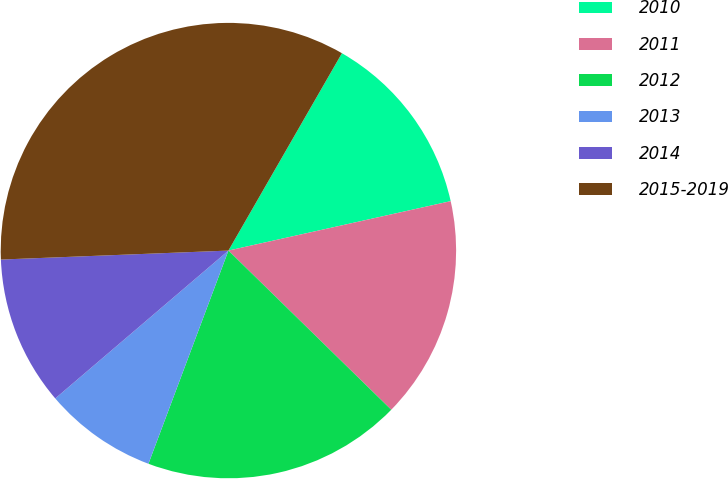Convert chart to OTSL. <chart><loc_0><loc_0><loc_500><loc_500><pie_chart><fcel>2010<fcel>2011<fcel>2012<fcel>2013<fcel>2014<fcel>2015-2019<nl><fcel>13.21%<fcel>15.8%<fcel>18.39%<fcel>8.04%<fcel>10.62%<fcel>33.93%<nl></chart> 